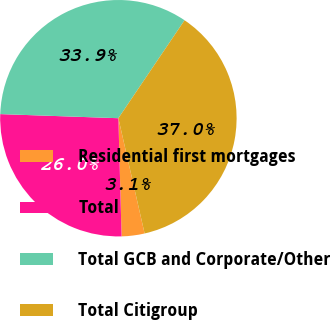<chart> <loc_0><loc_0><loc_500><loc_500><pie_chart><fcel>Residential first mortgages<fcel>Total<fcel>Total GCB and Corporate/Other<fcel>Total Citigroup<nl><fcel>3.13%<fcel>25.98%<fcel>33.9%<fcel>36.98%<nl></chart> 